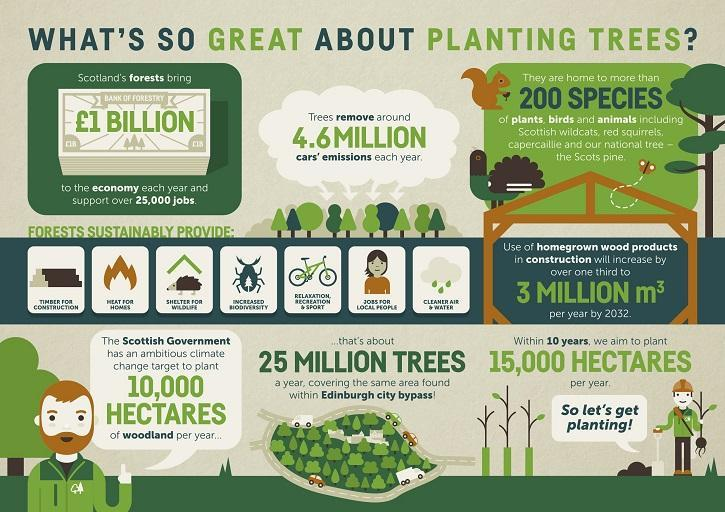How much is the forestry's economic contribution to Scotland each year?
Answer the question with a short phrase. £1 BILLION 